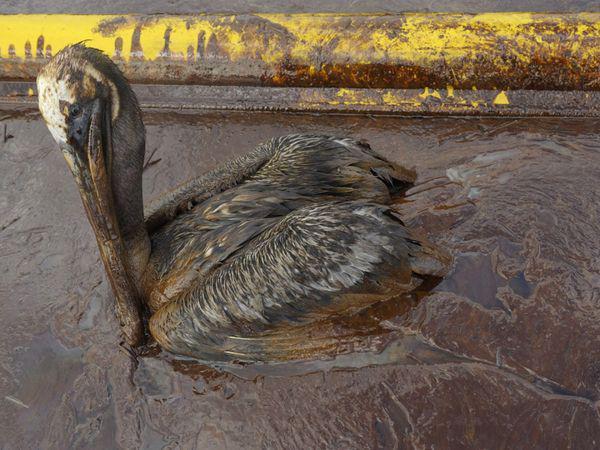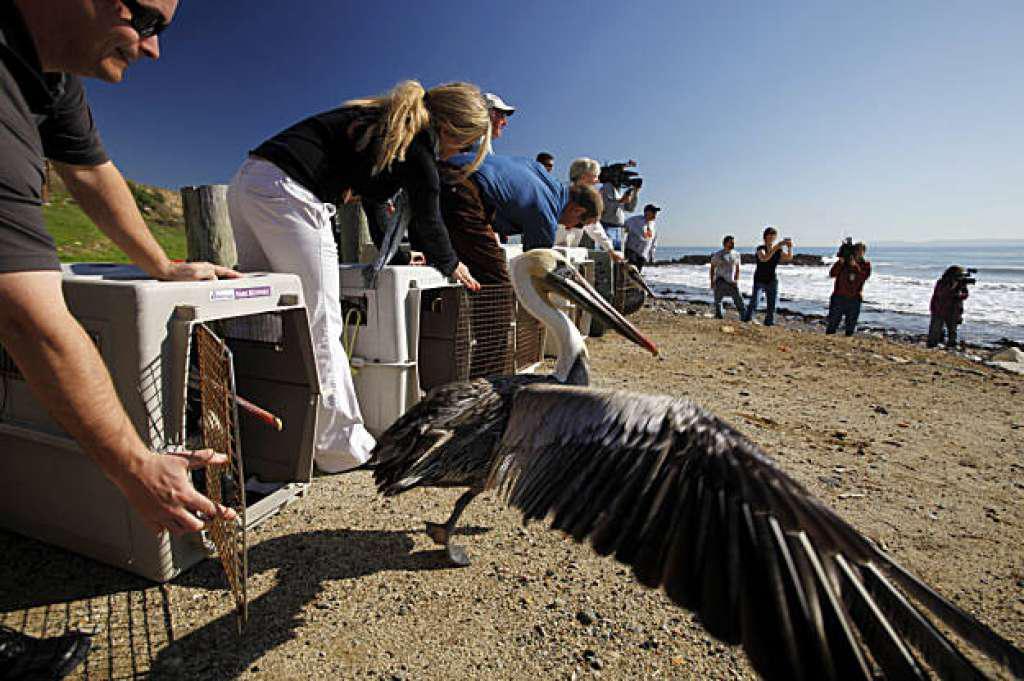The first image is the image on the left, the second image is the image on the right. Evaluate the accuracy of this statement regarding the images: "In one image, there is at least one person near a pelican.". Is it true? Answer yes or no. Yes. The first image is the image on the left, the second image is the image on the right. Examine the images to the left and right. Is the description "At least one person is interacting with birds in one image." accurate? Answer yes or no. Yes. 